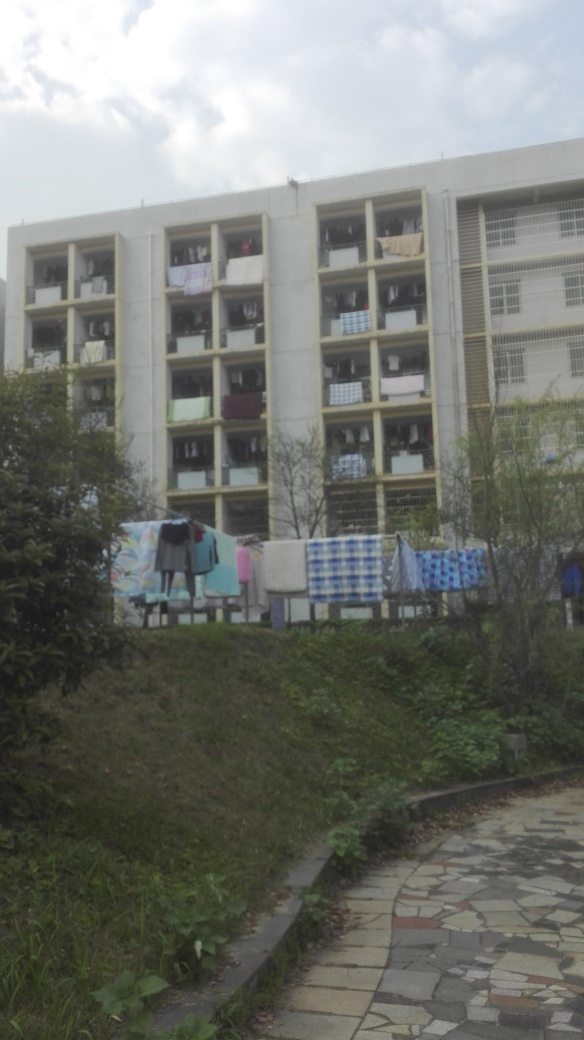What time of day does this image appear to depict? Based on the lighting and shadows, it seems to be taken in the mid-to-late afternoon. 